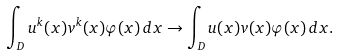<formula> <loc_0><loc_0><loc_500><loc_500>\int _ { D } u ^ { k } ( x ) v ^ { k } ( x ) \varphi ( x ) \, d x \to \int _ { D } u ( x ) v ( x ) \varphi ( x ) \, d x .</formula> 